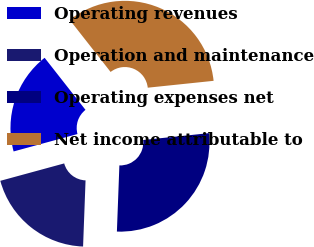Convert chart to OTSL. <chart><loc_0><loc_0><loc_500><loc_500><pie_chart><fcel>Operating revenues<fcel>Operation and maintenance<fcel>Operating expenses net<fcel>Net income attributable to<nl><fcel>18.64%<fcel>20.17%<fcel>27.25%<fcel>33.94%<nl></chart> 